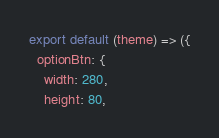Convert code to text. <code><loc_0><loc_0><loc_500><loc_500><_JavaScript_>export default (theme) => ({
  optionBtn: {
    width: 280,
    height: 80,</code> 